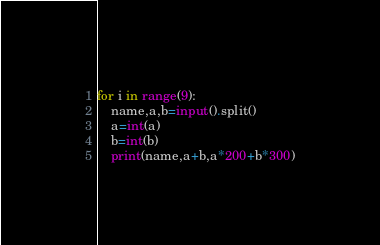Convert code to text. <code><loc_0><loc_0><loc_500><loc_500><_Python_>for i in range(9):
    name,a,b=input().split()
    a=int(a)
    b=int(b)
    print(name,a+b,a*200+b*300)
</code> 